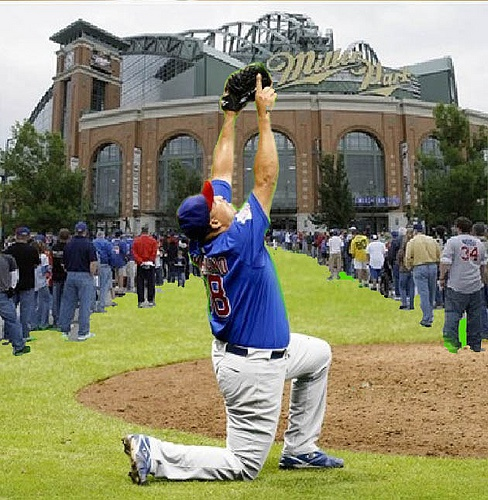Describe the objects in this image and their specific colors. I can see people in tan, lightgray, darkgray, black, and gray tones, people in tan, black, gray, navy, and darkgray tones, people in tan, black, gray, and darkgray tones, people in tan, black, gray, darkblue, and navy tones, and people in tan and gray tones in this image. 